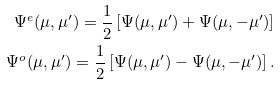Convert formula to latex. <formula><loc_0><loc_0><loc_500><loc_500>\Psi ^ { e } ( \mu , \mu ^ { \prime } ) = \frac { 1 } { 2 } \left [ \Psi ( \mu , \mu ^ { \prime } ) + \Psi ( \mu , - \mu ^ { \prime } ) \right ] \\ \Psi ^ { o } ( \mu , \mu ^ { \prime } ) = \frac { 1 } { 2 } \left [ \Psi ( \mu , \mu ^ { \prime } ) - \Psi ( \mu , - \mu ^ { \prime } ) \right ] .</formula> 